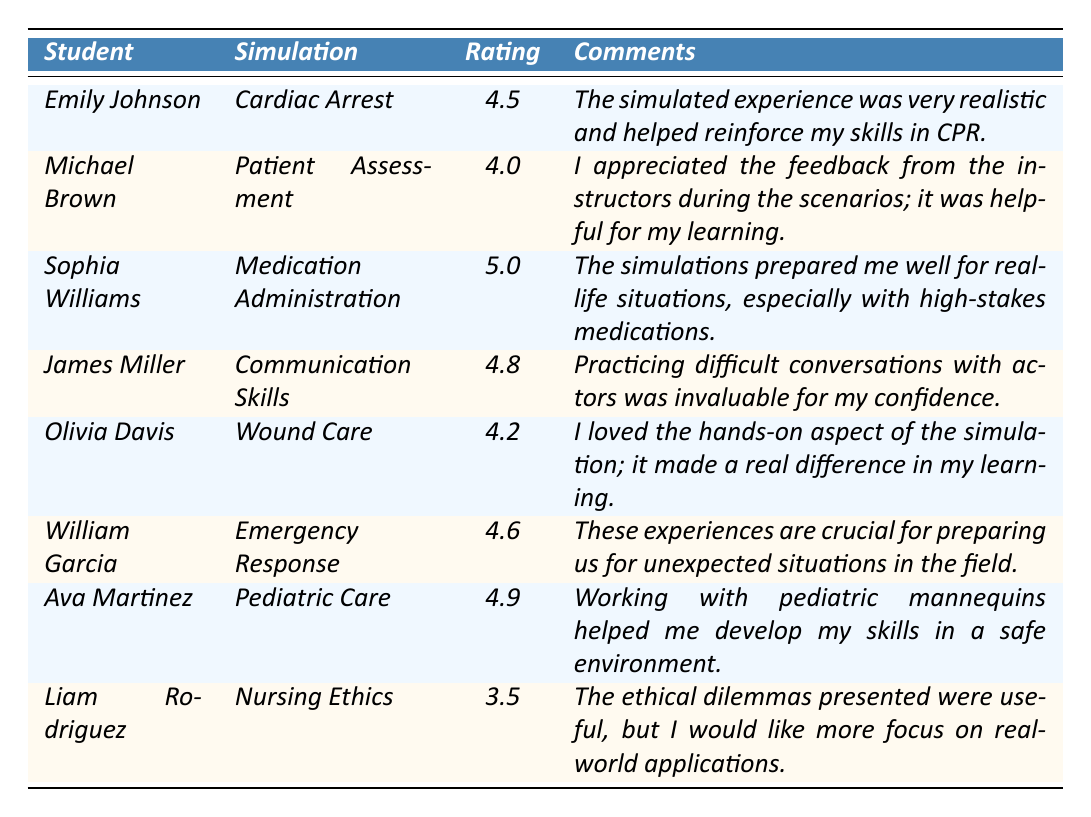What is the highest rating awarded by a student? The highest rating in the table is 5.0 given by Sophia Williams for the simulation on Medication Administration.
Answer: 5.0 What simulation type received the lowest rating? The simulation type with the lowest rating is Nursing Ethics, which received a rating of 3.5 from Liam Rodriguez.
Answer: Nursing Ethics What is the average rating for all simulations? To find the average rating, add all the ratings: (4.5 + 4.0 + 5.0 + 4.8 + 4.2 + 4.6 + 4.9 + 3.5) = 36.5. There are 8 ratings, so the average is 36.5/8 = 4.5625.
Answer: 4.56 Did any students comment on the realism of the simulations? Yes, Emily Johnson commented that "the simulated experience was very realistic," which indicates she appreciated the realism of her simulation.
Answer: Yes Which simulation type had the most positive feedback based on ratings? The simulation type with the most positive feedback is Medication Administration, rated 5.0 by Sophia Williams, indicating she found it extremely beneficial.
Answer: Medication Administration How many students rated their simulation experience above 4.5? Reviewing the ratings, Emily Johnson, Sophia Williams, James Miller, Olivia Davis, William Garcia, and Ava Martinez rated their experiences above 4.5. This totals to 6 students.
Answer: 6 Is there a simulation type mentioned where students expressed a desire for more practical applications? Yes, Liam Rodriguez expressed a desire for more focus on real-world applications in his comment about the Nursing Ethics simulation.
Answer: Yes What percentage of simulations received a rating of 4.5 or higher? There are 5 simulations with ratings of 4.5 or higher (Emily Johnson, Sophia Williams, James Miller, William Garcia, Ava Martinez) out of 8 total simulations. The percentage is (5/8) * 100 = 62.5%.
Answer: 62.5% 